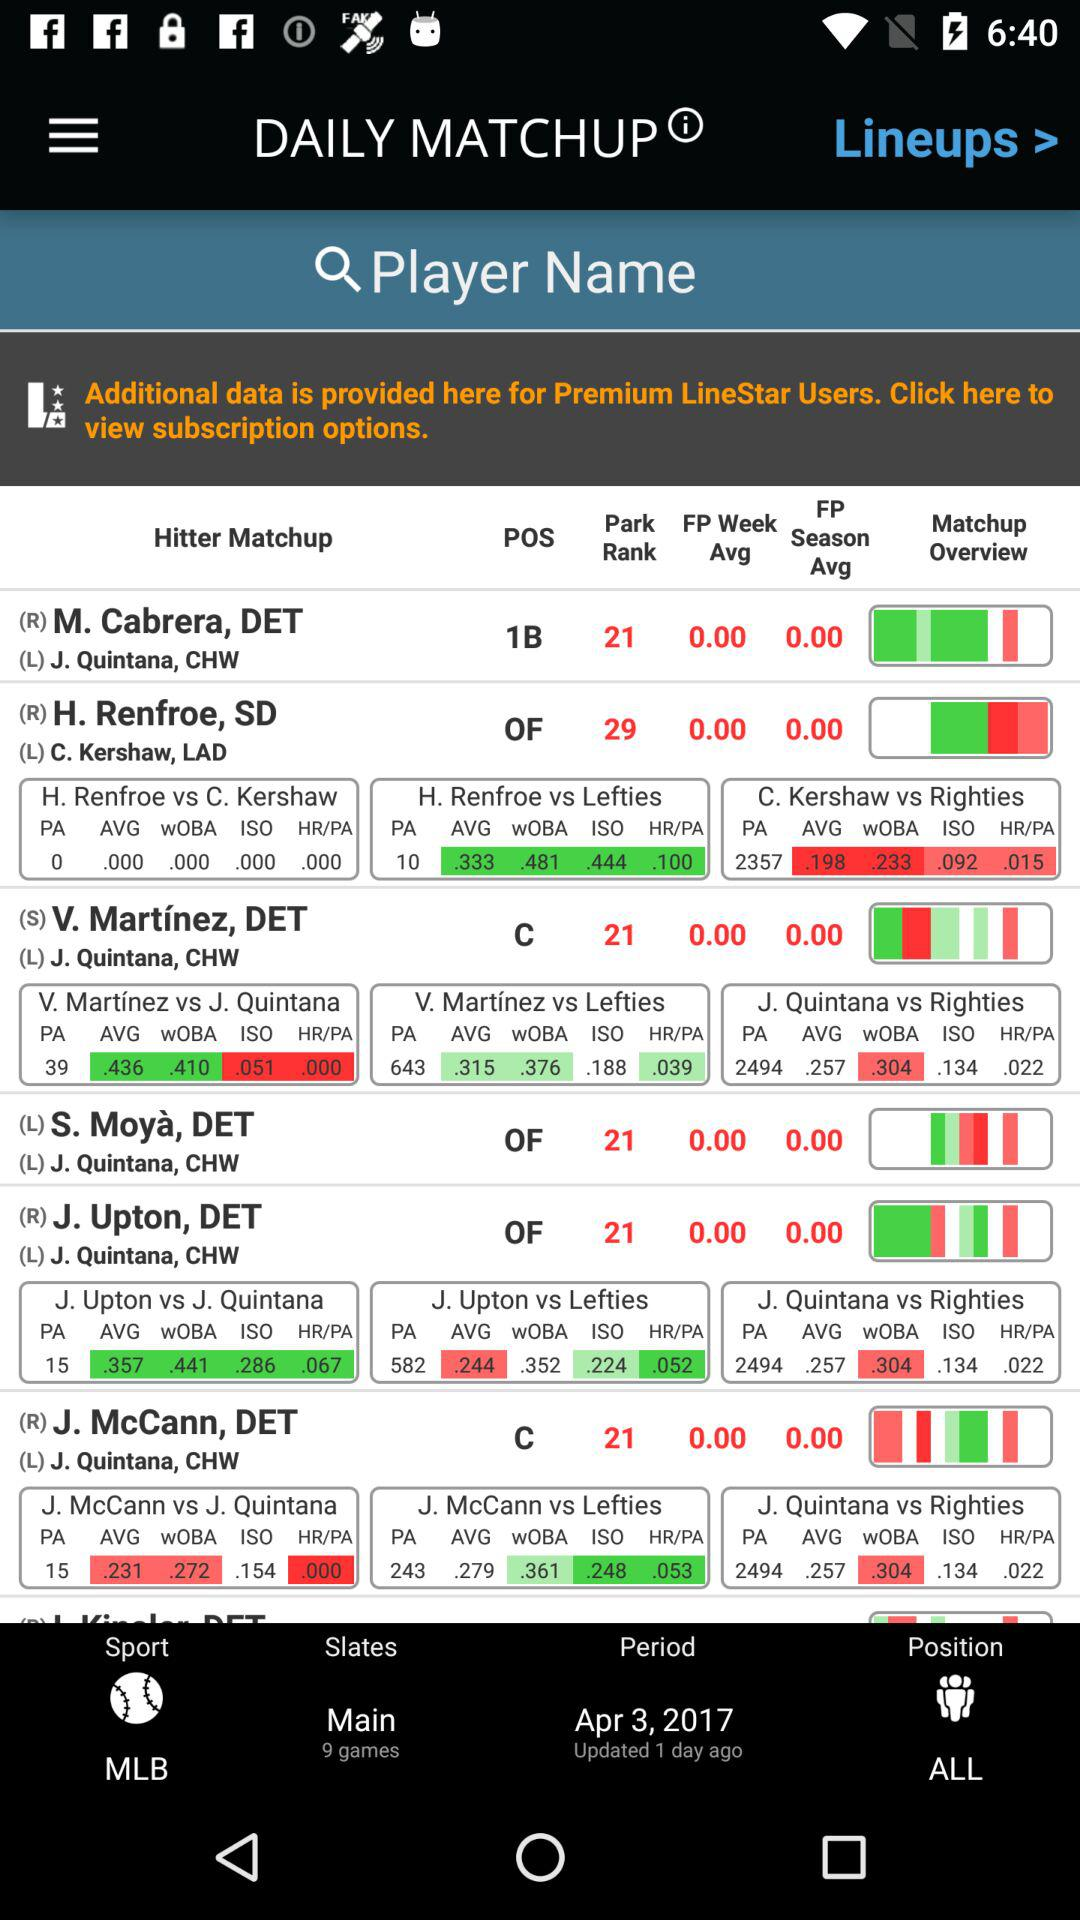What is the park rank of M.Cabrera? The park rank of M.Cabrera is 21. 